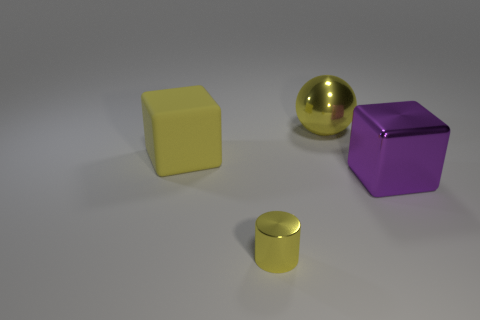Add 3 big yellow metal balls. How many objects exist? 7 Add 1 balls. How many balls exist? 2 Subtract 0 brown spheres. How many objects are left? 4 Subtract all spheres. How many objects are left? 3 Subtract all large purple metal blocks. Subtract all matte things. How many objects are left? 2 Add 3 large metallic spheres. How many large metallic spheres are left? 4 